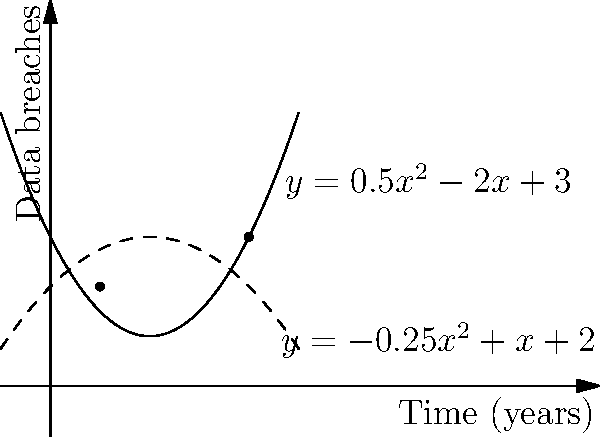Two tech companies have been tracking data breach incidents over time. Company A's data is represented by the parabola $y = 0.5x^2 - 2x + 3$, while Company B's data is represented by $y = -0.25x^2 + x + 2$, where $x$ is the time in years and $y$ is the number of data breaches. At how many points do these two parabolas intersect, and what are the coordinates of these intersection points? To find the intersection points, we need to solve the equation:

$$0.5x^2 - 2x + 3 = -0.25x^2 + x + 2$$

1) First, let's rearrange the equation:
   $$0.5x^2 - 2x + 3 + 0.25x^2 - x - 2 = 0$$

2) Simplify:
   $$0.75x^2 - 3x + 1 = 0$$

3) Multiply all terms by 4 to eliminate fractions:
   $$3x^2 - 12x + 4 = 0$$

4) This is a quadratic equation. We can solve it using the quadratic formula:
   $$x = \frac{-b \pm \sqrt{b^2 - 4ac}}{2a}$$
   where $a = 3$, $b = -12$, and $c = 4$

5) Plugging in these values:
   $$x = \frac{12 \pm \sqrt{144 - 48}}{6} = \frac{12 \pm \sqrt{96}}{6} = \frac{12 \pm 4\sqrt{6}}{6}$$

6) Simplifying:
   $$x = 2 \pm \frac{2\sqrt{6}}{3}$$

7) This gives us two solutions:
   $$x_1 = 2 + \frac{2\sqrt{6}}{3} \approx 4$$
   $$x_2 = 2 - \frac{2\sqrt{6}}{3} \approx 1$$

8) To find the y-coordinates, we can plug these x-values into either of the original equations. Let's use Company A's equation:

   For $x_1 \approx 4$:
   $$y = 0.5(4)^2 - 2(4) + 3 = 8 - 8 + 3 = 3$$

   For $x_2 \approx 1$:
   $$y = 0.5(1)^2 - 2(1) + 3 = 0.5 - 2 + 3 = 1.5 \approx 2$$

Therefore, the parabolas intersect at two points: approximately (1, 2) and (4, 3).
Answer: 2 points: (1, 2) and (4, 3) 